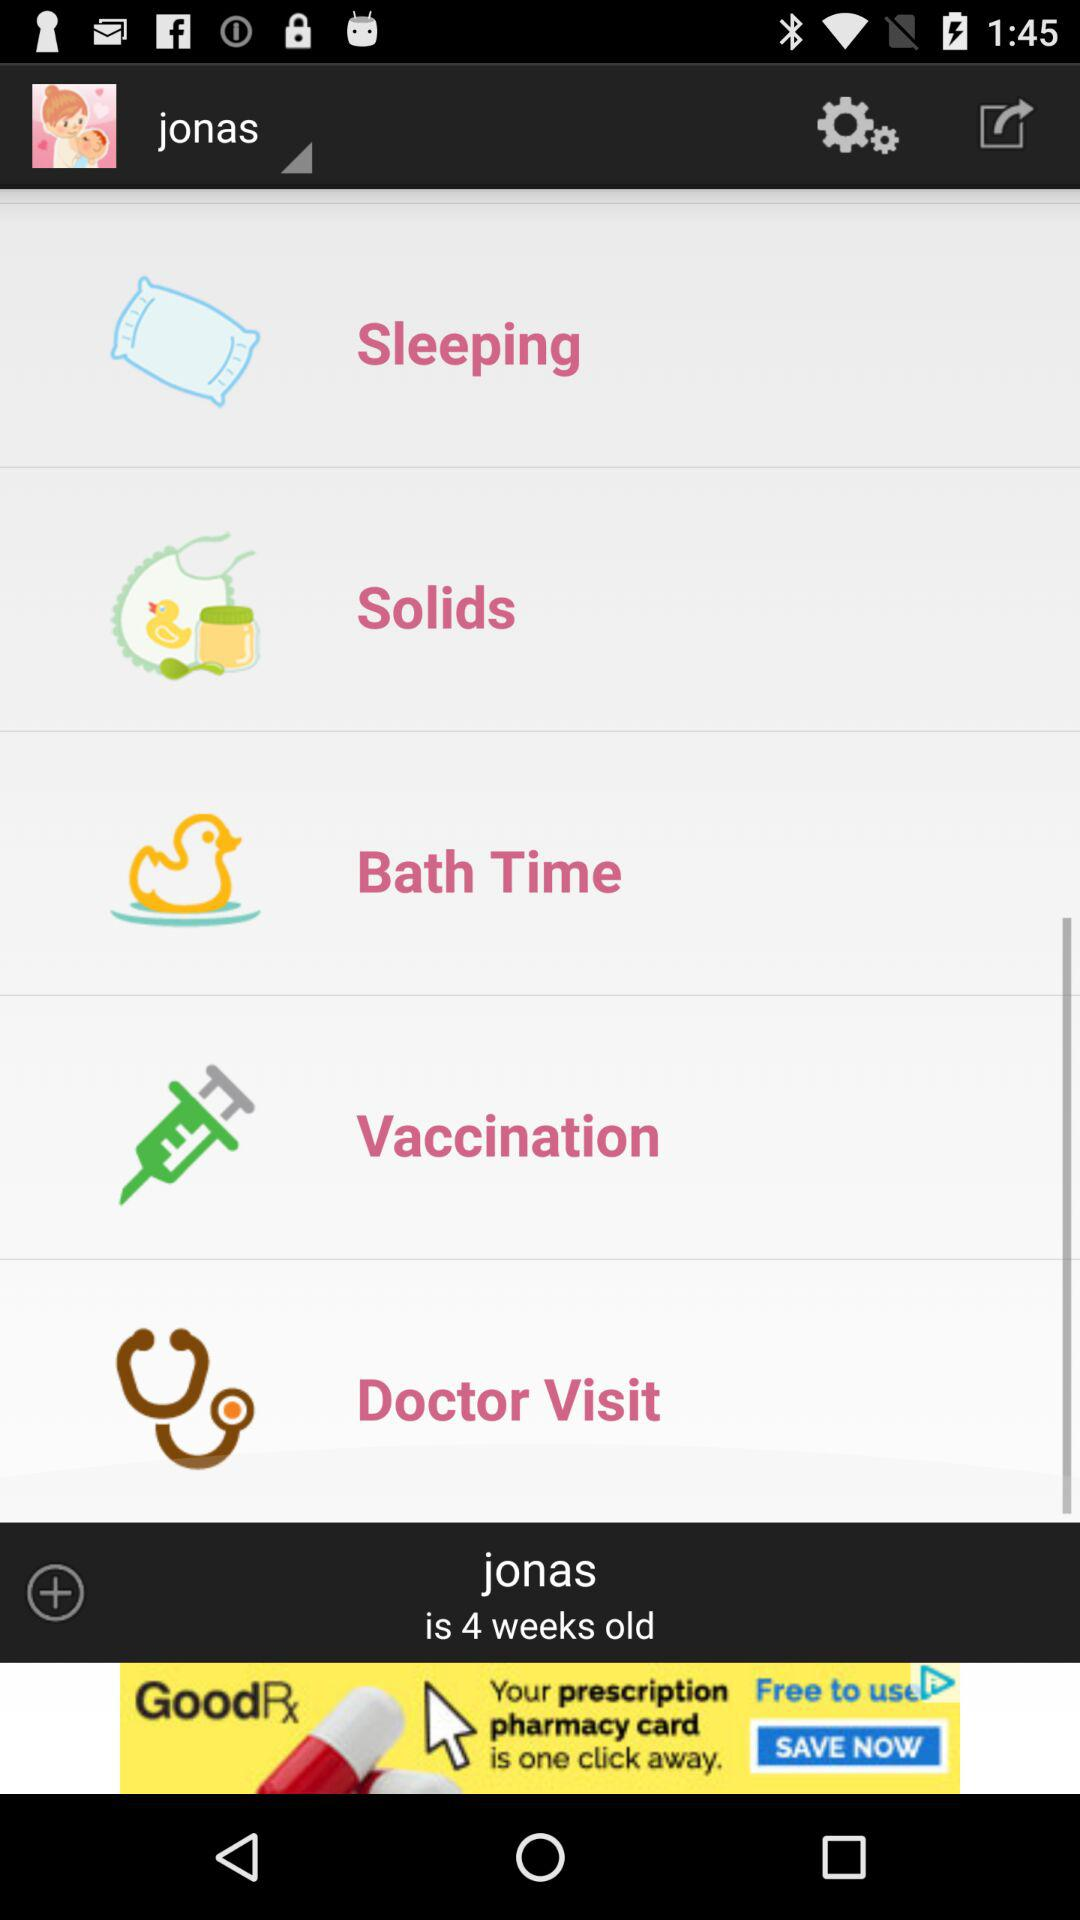What is the name of the user? The name of the user is jonas. 